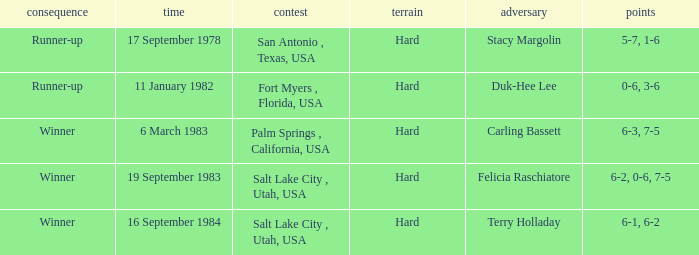What was the score of the match against duk-hee lee? 0-6, 3-6. 